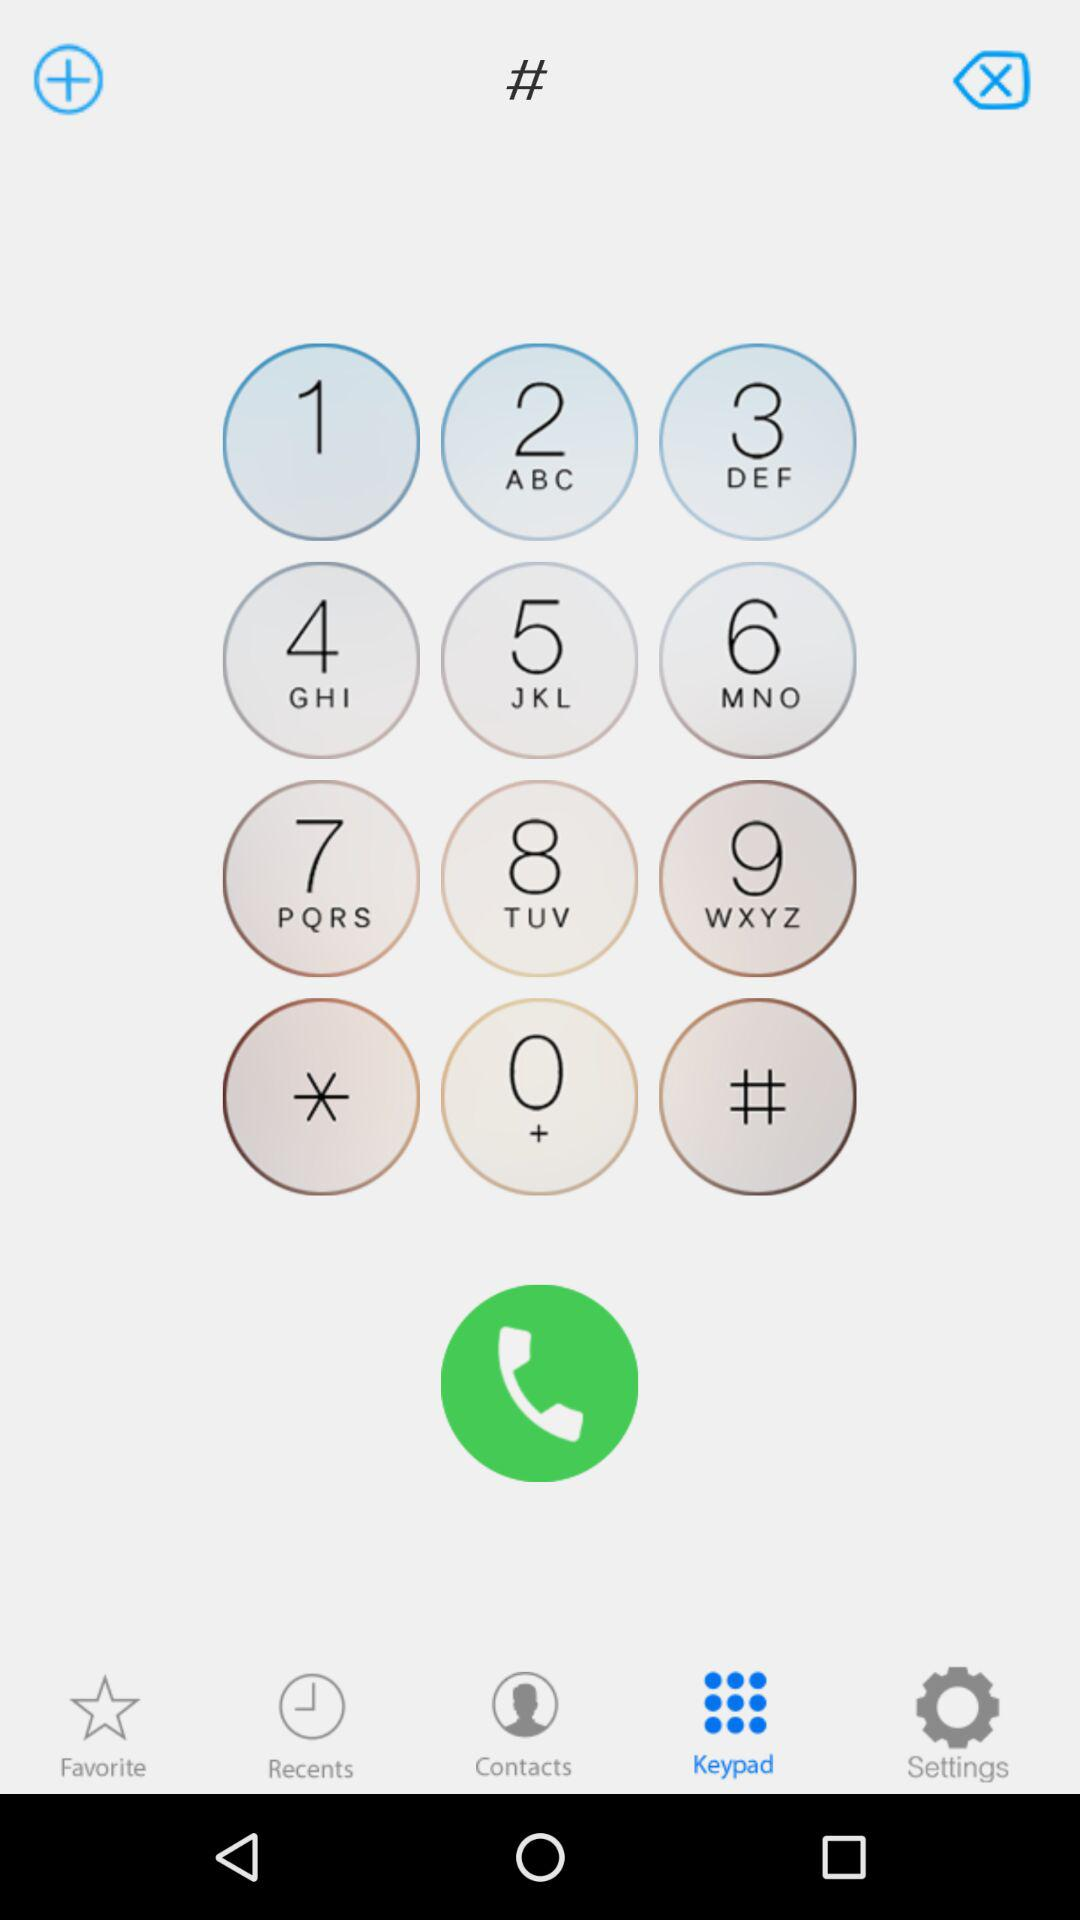Which alphabets are mentioned in button "4"? The mentioned alphabets in button "4" are G, H and I. 